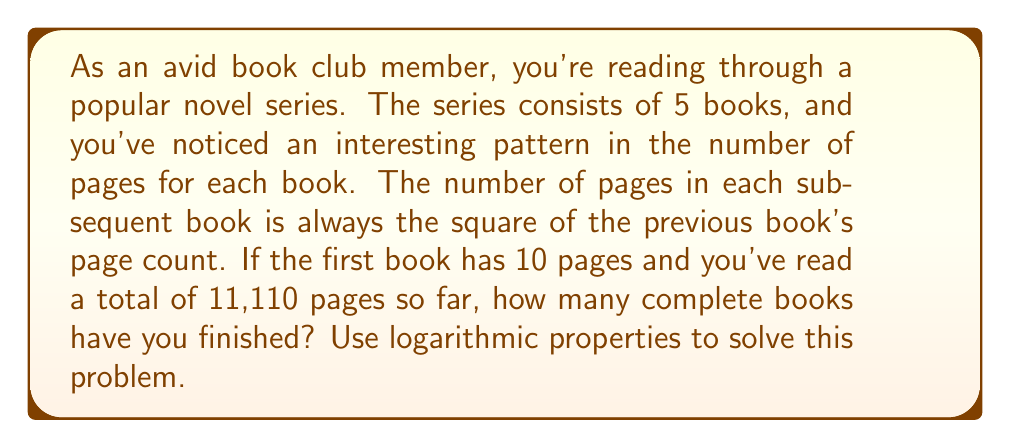Help me with this question. Let's approach this step-by-step using logarithmic properties:

1) First, let's establish the page counts for each book:
   Book 1: 10 pages
   Book 2: $10^2 = 100$ pages
   Book 3: $100^2 = 10,000$ pages
   Book 4: $10,000^2 = 100,000,000$ pages
   Book 5: $100,000,000^2 = 10,000,000,000,000$ pages

2) We can represent this sequence as:
   $10, 10^2, 10^4, 10^8, 10^{16}$

3) The sum of pages read so far is 11,110. We need to determine how many complete books this covers.

4) Let's subtract the pages of each book until we can't anymore:
   11,110 - 10 = 11,100
   11,100 - 100 = 11,000
   11,000 - 10,000 = -3,000

5) We can't subtract the third book completely, so we've finished 2 complete books.

6) To verify this using logarithms, we can use the following property:
   If $a^x = b$, then $\log_a b = x$

7) In our case, we want to find $x$ in the equation:
   $10^x = 11,110$

8) Taking the logarithm of both sides:
   $\log_{10} 11,110 = x$

9) Using a calculator or logarithm table:
   $x \approx 4.0458$

10) This means we're just past the 4th power of 10 in our sequence, confirming that we've completed 2 books and partially read the third.
Answer: The reader has finished 2 complete books in the series. 